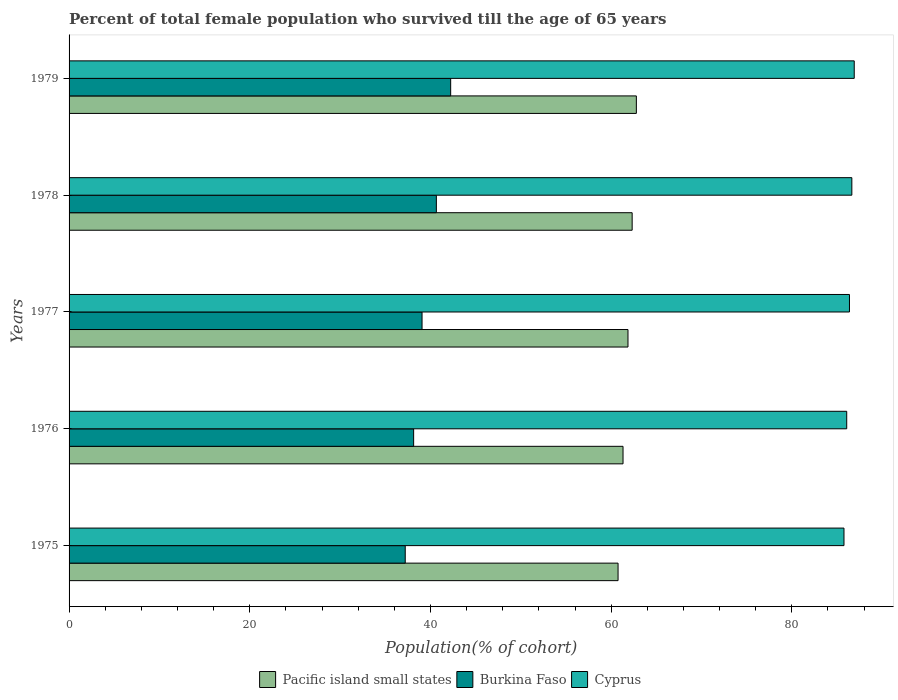How many different coloured bars are there?
Make the answer very short. 3. Are the number of bars per tick equal to the number of legend labels?
Your answer should be very brief. Yes. What is the percentage of total female population who survived till the age of 65 years in Burkina Faso in 1976?
Keep it short and to the point. 38.14. Across all years, what is the maximum percentage of total female population who survived till the age of 65 years in Cyprus?
Ensure brevity in your answer.  86.91. Across all years, what is the minimum percentage of total female population who survived till the age of 65 years in Pacific island small states?
Your response must be concise. 60.77. In which year was the percentage of total female population who survived till the age of 65 years in Burkina Faso maximum?
Your response must be concise. 1979. In which year was the percentage of total female population who survived till the age of 65 years in Pacific island small states minimum?
Your response must be concise. 1975. What is the total percentage of total female population who survived till the age of 65 years in Pacific island small states in the graph?
Give a very brief answer. 309.07. What is the difference between the percentage of total female population who survived till the age of 65 years in Burkina Faso in 1975 and that in 1979?
Ensure brevity in your answer.  -5.03. What is the difference between the percentage of total female population who survived till the age of 65 years in Cyprus in 1975 and the percentage of total female population who survived till the age of 65 years in Pacific island small states in 1976?
Your answer should be very brief. 24.46. What is the average percentage of total female population who survived till the age of 65 years in Burkina Faso per year?
Your response must be concise. 39.46. In the year 1979, what is the difference between the percentage of total female population who survived till the age of 65 years in Burkina Faso and percentage of total female population who survived till the age of 65 years in Cyprus?
Offer a very short reply. -44.67. In how many years, is the percentage of total female population who survived till the age of 65 years in Pacific island small states greater than 12 %?
Your answer should be compact. 5. What is the ratio of the percentage of total female population who survived till the age of 65 years in Burkina Faso in 1976 to that in 1978?
Give a very brief answer. 0.94. Is the difference between the percentage of total female population who survived till the age of 65 years in Burkina Faso in 1978 and 1979 greater than the difference between the percentage of total female population who survived till the age of 65 years in Cyprus in 1978 and 1979?
Provide a short and direct response. No. What is the difference between the highest and the second highest percentage of total female population who survived till the age of 65 years in Burkina Faso?
Ensure brevity in your answer.  1.58. What is the difference between the highest and the lowest percentage of total female population who survived till the age of 65 years in Cyprus?
Keep it short and to the point. 1.13. In how many years, is the percentage of total female population who survived till the age of 65 years in Cyprus greater than the average percentage of total female population who survived till the age of 65 years in Cyprus taken over all years?
Your answer should be compact. 3. What does the 2nd bar from the top in 1977 represents?
Your answer should be very brief. Burkina Faso. What does the 3rd bar from the bottom in 1975 represents?
Your answer should be very brief. Cyprus. Is it the case that in every year, the sum of the percentage of total female population who survived till the age of 65 years in Cyprus and percentage of total female population who survived till the age of 65 years in Burkina Faso is greater than the percentage of total female population who survived till the age of 65 years in Pacific island small states?
Your response must be concise. Yes. Are all the bars in the graph horizontal?
Make the answer very short. Yes. What is the difference between two consecutive major ticks on the X-axis?
Make the answer very short. 20. Are the values on the major ticks of X-axis written in scientific E-notation?
Keep it short and to the point. No. How many legend labels are there?
Your answer should be compact. 3. What is the title of the graph?
Provide a short and direct response. Percent of total female population who survived till the age of 65 years. Does "Lesotho" appear as one of the legend labels in the graph?
Make the answer very short. No. What is the label or title of the X-axis?
Ensure brevity in your answer.  Population(% of cohort). What is the Population(% of cohort) in Pacific island small states in 1975?
Ensure brevity in your answer.  60.77. What is the Population(% of cohort) of Burkina Faso in 1975?
Offer a very short reply. 37.21. What is the Population(% of cohort) in Cyprus in 1975?
Provide a succinct answer. 85.77. What is the Population(% of cohort) in Pacific island small states in 1976?
Offer a very short reply. 61.32. What is the Population(% of cohort) of Burkina Faso in 1976?
Provide a succinct answer. 38.14. What is the Population(% of cohort) of Cyprus in 1976?
Make the answer very short. 86.08. What is the Population(% of cohort) in Pacific island small states in 1977?
Make the answer very short. 61.86. What is the Population(% of cohort) of Burkina Faso in 1977?
Your response must be concise. 39.07. What is the Population(% of cohort) in Cyprus in 1977?
Your answer should be compact. 86.38. What is the Population(% of cohort) in Pacific island small states in 1978?
Make the answer very short. 62.33. What is the Population(% of cohort) in Burkina Faso in 1978?
Your answer should be compact. 40.65. What is the Population(% of cohort) in Cyprus in 1978?
Offer a very short reply. 86.64. What is the Population(% of cohort) in Pacific island small states in 1979?
Your answer should be very brief. 62.79. What is the Population(% of cohort) of Burkina Faso in 1979?
Your response must be concise. 42.24. What is the Population(% of cohort) of Cyprus in 1979?
Offer a very short reply. 86.91. Across all years, what is the maximum Population(% of cohort) in Pacific island small states?
Your response must be concise. 62.79. Across all years, what is the maximum Population(% of cohort) of Burkina Faso?
Give a very brief answer. 42.24. Across all years, what is the maximum Population(% of cohort) of Cyprus?
Provide a succinct answer. 86.91. Across all years, what is the minimum Population(% of cohort) of Pacific island small states?
Offer a very short reply. 60.77. Across all years, what is the minimum Population(% of cohort) of Burkina Faso?
Offer a very short reply. 37.21. Across all years, what is the minimum Population(% of cohort) of Cyprus?
Provide a short and direct response. 85.77. What is the total Population(% of cohort) in Pacific island small states in the graph?
Give a very brief answer. 309.07. What is the total Population(% of cohort) of Burkina Faso in the graph?
Offer a very short reply. 197.31. What is the total Population(% of cohort) in Cyprus in the graph?
Your answer should be compact. 431.78. What is the difference between the Population(% of cohort) in Pacific island small states in 1975 and that in 1976?
Provide a short and direct response. -0.55. What is the difference between the Population(% of cohort) of Burkina Faso in 1975 and that in 1976?
Provide a short and direct response. -0.93. What is the difference between the Population(% of cohort) in Cyprus in 1975 and that in 1976?
Provide a short and direct response. -0.3. What is the difference between the Population(% of cohort) in Pacific island small states in 1975 and that in 1977?
Your answer should be compact. -1.1. What is the difference between the Population(% of cohort) in Burkina Faso in 1975 and that in 1977?
Offer a terse response. -1.86. What is the difference between the Population(% of cohort) of Cyprus in 1975 and that in 1977?
Provide a short and direct response. -0.61. What is the difference between the Population(% of cohort) of Pacific island small states in 1975 and that in 1978?
Make the answer very short. -1.56. What is the difference between the Population(% of cohort) of Burkina Faso in 1975 and that in 1978?
Provide a succinct answer. -3.45. What is the difference between the Population(% of cohort) in Cyprus in 1975 and that in 1978?
Your answer should be very brief. -0.87. What is the difference between the Population(% of cohort) in Pacific island small states in 1975 and that in 1979?
Make the answer very short. -2.02. What is the difference between the Population(% of cohort) in Burkina Faso in 1975 and that in 1979?
Offer a terse response. -5.03. What is the difference between the Population(% of cohort) of Cyprus in 1975 and that in 1979?
Give a very brief answer. -1.13. What is the difference between the Population(% of cohort) of Pacific island small states in 1976 and that in 1977?
Ensure brevity in your answer.  -0.55. What is the difference between the Population(% of cohort) in Burkina Faso in 1976 and that in 1977?
Keep it short and to the point. -0.93. What is the difference between the Population(% of cohort) of Cyprus in 1976 and that in 1977?
Your answer should be compact. -0.3. What is the difference between the Population(% of cohort) in Pacific island small states in 1976 and that in 1978?
Give a very brief answer. -1.01. What is the difference between the Population(% of cohort) in Burkina Faso in 1976 and that in 1978?
Give a very brief answer. -2.51. What is the difference between the Population(% of cohort) in Cyprus in 1976 and that in 1978?
Ensure brevity in your answer.  -0.57. What is the difference between the Population(% of cohort) in Pacific island small states in 1976 and that in 1979?
Your answer should be very brief. -1.48. What is the difference between the Population(% of cohort) of Burkina Faso in 1976 and that in 1979?
Provide a succinct answer. -4.1. What is the difference between the Population(% of cohort) of Cyprus in 1976 and that in 1979?
Keep it short and to the point. -0.83. What is the difference between the Population(% of cohort) of Pacific island small states in 1977 and that in 1978?
Keep it short and to the point. -0.46. What is the difference between the Population(% of cohort) of Burkina Faso in 1977 and that in 1978?
Offer a very short reply. -1.58. What is the difference between the Population(% of cohort) in Cyprus in 1977 and that in 1978?
Your response must be concise. -0.26. What is the difference between the Population(% of cohort) in Pacific island small states in 1977 and that in 1979?
Keep it short and to the point. -0.93. What is the difference between the Population(% of cohort) in Burkina Faso in 1977 and that in 1979?
Your answer should be very brief. -3.17. What is the difference between the Population(% of cohort) in Cyprus in 1977 and that in 1979?
Keep it short and to the point. -0.53. What is the difference between the Population(% of cohort) of Pacific island small states in 1978 and that in 1979?
Keep it short and to the point. -0.46. What is the difference between the Population(% of cohort) in Burkina Faso in 1978 and that in 1979?
Your answer should be very brief. -1.58. What is the difference between the Population(% of cohort) in Cyprus in 1978 and that in 1979?
Give a very brief answer. -0.26. What is the difference between the Population(% of cohort) of Pacific island small states in 1975 and the Population(% of cohort) of Burkina Faso in 1976?
Ensure brevity in your answer.  22.63. What is the difference between the Population(% of cohort) of Pacific island small states in 1975 and the Population(% of cohort) of Cyprus in 1976?
Offer a very short reply. -25.31. What is the difference between the Population(% of cohort) in Burkina Faso in 1975 and the Population(% of cohort) in Cyprus in 1976?
Your answer should be very brief. -48.87. What is the difference between the Population(% of cohort) in Pacific island small states in 1975 and the Population(% of cohort) in Burkina Faso in 1977?
Your response must be concise. 21.7. What is the difference between the Population(% of cohort) of Pacific island small states in 1975 and the Population(% of cohort) of Cyprus in 1977?
Your answer should be very brief. -25.61. What is the difference between the Population(% of cohort) in Burkina Faso in 1975 and the Population(% of cohort) in Cyprus in 1977?
Your answer should be compact. -49.17. What is the difference between the Population(% of cohort) of Pacific island small states in 1975 and the Population(% of cohort) of Burkina Faso in 1978?
Provide a succinct answer. 20.11. What is the difference between the Population(% of cohort) in Pacific island small states in 1975 and the Population(% of cohort) in Cyprus in 1978?
Your answer should be compact. -25.88. What is the difference between the Population(% of cohort) in Burkina Faso in 1975 and the Population(% of cohort) in Cyprus in 1978?
Your response must be concise. -49.43. What is the difference between the Population(% of cohort) in Pacific island small states in 1975 and the Population(% of cohort) in Burkina Faso in 1979?
Your response must be concise. 18.53. What is the difference between the Population(% of cohort) in Pacific island small states in 1975 and the Population(% of cohort) in Cyprus in 1979?
Offer a terse response. -26.14. What is the difference between the Population(% of cohort) in Burkina Faso in 1975 and the Population(% of cohort) in Cyprus in 1979?
Your answer should be very brief. -49.7. What is the difference between the Population(% of cohort) in Pacific island small states in 1976 and the Population(% of cohort) in Burkina Faso in 1977?
Provide a succinct answer. 22.25. What is the difference between the Population(% of cohort) of Pacific island small states in 1976 and the Population(% of cohort) of Cyprus in 1977?
Provide a short and direct response. -25.06. What is the difference between the Population(% of cohort) of Burkina Faso in 1976 and the Population(% of cohort) of Cyprus in 1977?
Offer a very short reply. -48.24. What is the difference between the Population(% of cohort) in Pacific island small states in 1976 and the Population(% of cohort) in Burkina Faso in 1978?
Offer a terse response. 20.66. What is the difference between the Population(% of cohort) in Pacific island small states in 1976 and the Population(% of cohort) in Cyprus in 1978?
Your answer should be very brief. -25.33. What is the difference between the Population(% of cohort) in Burkina Faso in 1976 and the Population(% of cohort) in Cyprus in 1978?
Your answer should be compact. -48.5. What is the difference between the Population(% of cohort) in Pacific island small states in 1976 and the Population(% of cohort) in Burkina Faso in 1979?
Ensure brevity in your answer.  19.08. What is the difference between the Population(% of cohort) in Pacific island small states in 1976 and the Population(% of cohort) in Cyprus in 1979?
Provide a short and direct response. -25.59. What is the difference between the Population(% of cohort) in Burkina Faso in 1976 and the Population(% of cohort) in Cyprus in 1979?
Offer a very short reply. -48.77. What is the difference between the Population(% of cohort) in Pacific island small states in 1977 and the Population(% of cohort) in Burkina Faso in 1978?
Give a very brief answer. 21.21. What is the difference between the Population(% of cohort) of Pacific island small states in 1977 and the Population(% of cohort) of Cyprus in 1978?
Your answer should be very brief. -24.78. What is the difference between the Population(% of cohort) of Burkina Faso in 1977 and the Population(% of cohort) of Cyprus in 1978?
Your answer should be compact. -47.57. What is the difference between the Population(% of cohort) of Pacific island small states in 1977 and the Population(% of cohort) of Burkina Faso in 1979?
Keep it short and to the point. 19.63. What is the difference between the Population(% of cohort) of Pacific island small states in 1977 and the Population(% of cohort) of Cyprus in 1979?
Keep it short and to the point. -25.04. What is the difference between the Population(% of cohort) in Burkina Faso in 1977 and the Population(% of cohort) in Cyprus in 1979?
Make the answer very short. -47.84. What is the difference between the Population(% of cohort) in Pacific island small states in 1978 and the Population(% of cohort) in Burkina Faso in 1979?
Your answer should be very brief. 20.09. What is the difference between the Population(% of cohort) in Pacific island small states in 1978 and the Population(% of cohort) in Cyprus in 1979?
Provide a succinct answer. -24.58. What is the difference between the Population(% of cohort) in Burkina Faso in 1978 and the Population(% of cohort) in Cyprus in 1979?
Ensure brevity in your answer.  -46.25. What is the average Population(% of cohort) in Pacific island small states per year?
Your response must be concise. 61.81. What is the average Population(% of cohort) in Burkina Faso per year?
Ensure brevity in your answer.  39.46. What is the average Population(% of cohort) of Cyprus per year?
Your response must be concise. 86.36. In the year 1975, what is the difference between the Population(% of cohort) in Pacific island small states and Population(% of cohort) in Burkina Faso?
Make the answer very short. 23.56. In the year 1975, what is the difference between the Population(% of cohort) of Pacific island small states and Population(% of cohort) of Cyprus?
Keep it short and to the point. -25.01. In the year 1975, what is the difference between the Population(% of cohort) of Burkina Faso and Population(% of cohort) of Cyprus?
Offer a very short reply. -48.56. In the year 1976, what is the difference between the Population(% of cohort) of Pacific island small states and Population(% of cohort) of Burkina Faso?
Provide a short and direct response. 23.18. In the year 1976, what is the difference between the Population(% of cohort) of Pacific island small states and Population(% of cohort) of Cyprus?
Your answer should be very brief. -24.76. In the year 1976, what is the difference between the Population(% of cohort) of Burkina Faso and Population(% of cohort) of Cyprus?
Ensure brevity in your answer.  -47.94. In the year 1977, what is the difference between the Population(% of cohort) in Pacific island small states and Population(% of cohort) in Burkina Faso?
Your answer should be compact. 22.79. In the year 1977, what is the difference between the Population(% of cohort) of Pacific island small states and Population(% of cohort) of Cyprus?
Give a very brief answer. -24.52. In the year 1977, what is the difference between the Population(% of cohort) in Burkina Faso and Population(% of cohort) in Cyprus?
Provide a short and direct response. -47.31. In the year 1978, what is the difference between the Population(% of cohort) of Pacific island small states and Population(% of cohort) of Burkina Faso?
Your answer should be very brief. 21.67. In the year 1978, what is the difference between the Population(% of cohort) in Pacific island small states and Population(% of cohort) in Cyprus?
Offer a very short reply. -24.32. In the year 1978, what is the difference between the Population(% of cohort) of Burkina Faso and Population(% of cohort) of Cyprus?
Keep it short and to the point. -45.99. In the year 1979, what is the difference between the Population(% of cohort) in Pacific island small states and Population(% of cohort) in Burkina Faso?
Your response must be concise. 20.55. In the year 1979, what is the difference between the Population(% of cohort) of Pacific island small states and Population(% of cohort) of Cyprus?
Your response must be concise. -24.12. In the year 1979, what is the difference between the Population(% of cohort) in Burkina Faso and Population(% of cohort) in Cyprus?
Offer a terse response. -44.67. What is the ratio of the Population(% of cohort) in Pacific island small states in 1975 to that in 1976?
Your answer should be compact. 0.99. What is the ratio of the Population(% of cohort) of Burkina Faso in 1975 to that in 1976?
Ensure brevity in your answer.  0.98. What is the ratio of the Population(% of cohort) of Pacific island small states in 1975 to that in 1977?
Give a very brief answer. 0.98. What is the ratio of the Population(% of cohort) in Cyprus in 1975 to that in 1977?
Provide a succinct answer. 0.99. What is the ratio of the Population(% of cohort) in Burkina Faso in 1975 to that in 1978?
Your answer should be very brief. 0.92. What is the ratio of the Population(% of cohort) in Cyprus in 1975 to that in 1978?
Make the answer very short. 0.99. What is the ratio of the Population(% of cohort) of Pacific island small states in 1975 to that in 1979?
Ensure brevity in your answer.  0.97. What is the ratio of the Population(% of cohort) of Burkina Faso in 1975 to that in 1979?
Make the answer very short. 0.88. What is the ratio of the Population(% of cohort) of Cyprus in 1975 to that in 1979?
Your answer should be very brief. 0.99. What is the ratio of the Population(% of cohort) of Burkina Faso in 1976 to that in 1977?
Provide a succinct answer. 0.98. What is the ratio of the Population(% of cohort) of Cyprus in 1976 to that in 1977?
Provide a short and direct response. 1. What is the ratio of the Population(% of cohort) in Pacific island small states in 1976 to that in 1978?
Make the answer very short. 0.98. What is the ratio of the Population(% of cohort) of Burkina Faso in 1976 to that in 1978?
Your response must be concise. 0.94. What is the ratio of the Population(% of cohort) in Cyprus in 1976 to that in 1978?
Ensure brevity in your answer.  0.99. What is the ratio of the Population(% of cohort) of Pacific island small states in 1976 to that in 1979?
Your response must be concise. 0.98. What is the ratio of the Population(% of cohort) of Burkina Faso in 1976 to that in 1979?
Offer a terse response. 0.9. What is the ratio of the Population(% of cohort) in Cyprus in 1976 to that in 1979?
Offer a terse response. 0.99. What is the ratio of the Population(% of cohort) in Pacific island small states in 1977 to that in 1978?
Your answer should be very brief. 0.99. What is the ratio of the Population(% of cohort) in Burkina Faso in 1977 to that in 1978?
Ensure brevity in your answer.  0.96. What is the ratio of the Population(% of cohort) of Pacific island small states in 1977 to that in 1979?
Your answer should be compact. 0.99. What is the ratio of the Population(% of cohort) in Burkina Faso in 1977 to that in 1979?
Your response must be concise. 0.93. What is the ratio of the Population(% of cohort) of Burkina Faso in 1978 to that in 1979?
Keep it short and to the point. 0.96. What is the difference between the highest and the second highest Population(% of cohort) in Pacific island small states?
Your response must be concise. 0.46. What is the difference between the highest and the second highest Population(% of cohort) in Burkina Faso?
Keep it short and to the point. 1.58. What is the difference between the highest and the second highest Population(% of cohort) of Cyprus?
Offer a terse response. 0.26. What is the difference between the highest and the lowest Population(% of cohort) of Pacific island small states?
Your answer should be very brief. 2.02. What is the difference between the highest and the lowest Population(% of cohort) of Burkina Faso?
Ensure brevity in your answer.  5.03. What is the difference between the highest and the lowest Population(% of cohort) in Cyprus?
Offer a terse response. 1.13. 